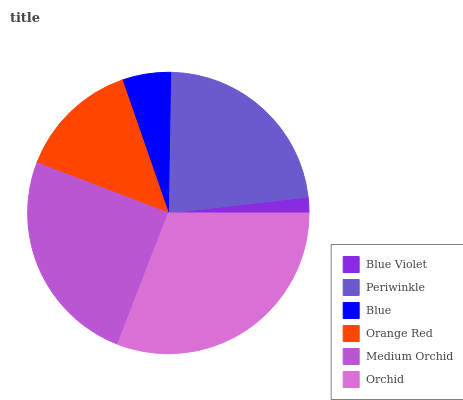Is Blue Violet the minimum?
Answer yes or no. Yes. Is Orchid the maximum?
Answer yes or no. Yes. Is Periwinkle the minimum?
Answer yes or no. No. Is Periwinkle the maximum?
Answer yes or no. No. Is Periwinkle greater than Blue Violet?
Answer yes or no. Yes. Is Blue Violet less than Periwinkle?
Answer yes or no. Yes. Is Blue Violet greater than Periwinkle?
Answer yes or no. No. Is Periwinkle less than Blue Violet?
Answer yes or no. No. Is Periwinkle the high median?
Answer yes or no. Yes. Is Orange Red the low median?
Answer yes or no. Yes. Is Blue the high median?
Answer yes or no. No. Is Medium Orchid the low median?
Answer yes or no. No. 